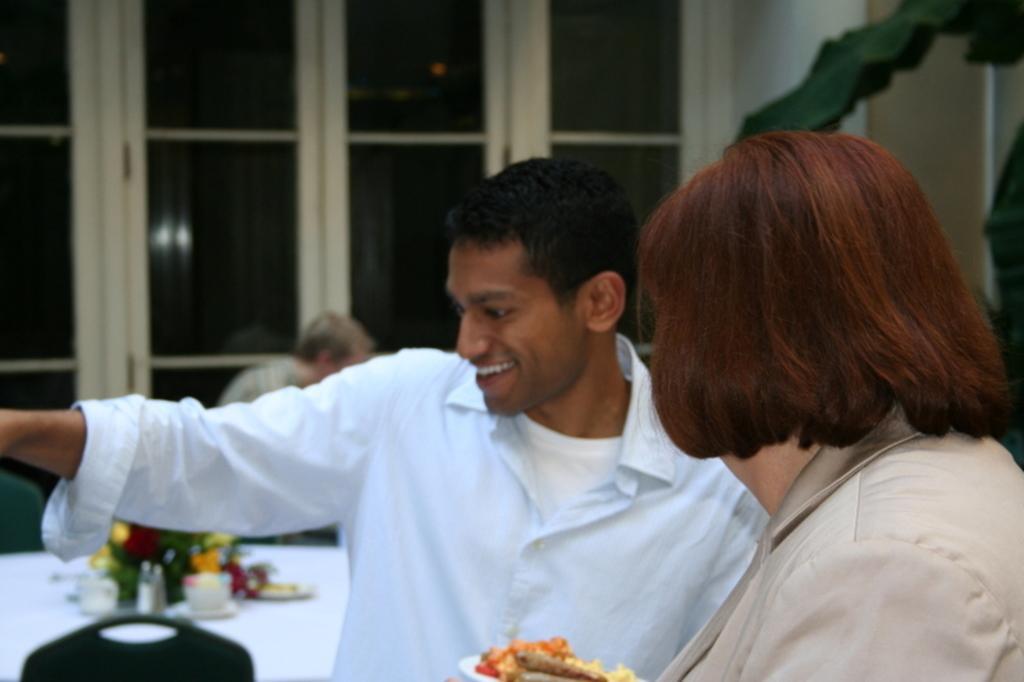In one or two sentences, can you explain what this image depicts? In this image I can see three persons and a table on which flower vase and plates are there. In the background I can see a wall, window and a houseplant. This image is taken may be in a hall. 